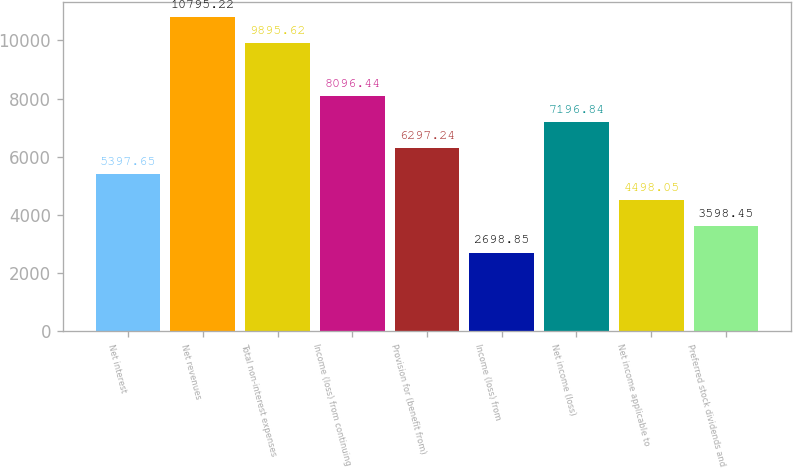Convert chart. <chart><loc_0><loc_0><loc_500><loc_500><bar_chart><fcel>Net interest<fcel>Net revenues<fcel>Total non-interest expenses<fcel>Income (loss) from continuing<fcel>Provision for (benefit from)<fcel>Income (loss) from<fcel>Net income (loss)<fcel>Net income applicable to<fcel>Preferred stock dividends and<nl><fcel>5397.65<fcel>10795.2<fcel>9895.62<fcel>8096.44<fcel>6297.24<fcel>2698.85<fcel>7196.84<fcel>4498.05<fcel>3598.45<nl></chart> 